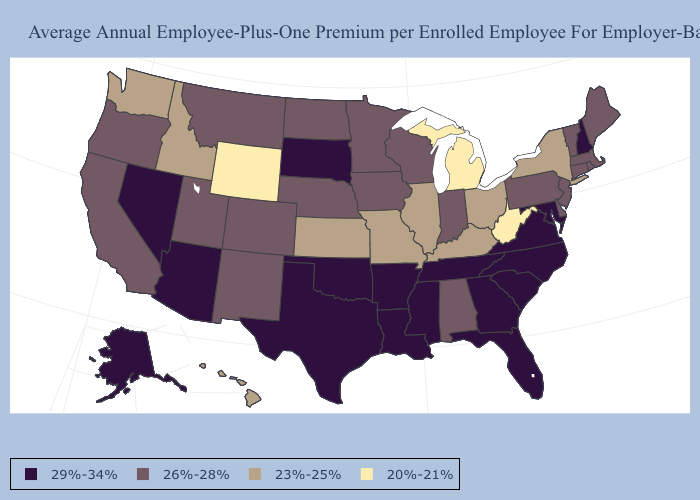Does New Hampshire have the highest value in the USA?
Quick response, please. Yes. Name the states that have a value in the range 23%-25%?
Quick response, please. Hawaii, Idaho, Illinois, Kansas, Kentucky, Missouri, New York, Ohio, Washington. Does Kentucky have a lower value than Oregon?
Write a very short answer. Yes. Name the states that have a value in the range 20%-21%?
Quick response, please. Michigan, West Virginia, Wyoming. Does Connecticut have the highest value in the Northeast?
Concise answer only. No. Which states have the lowest value in the USA?
Keep it brief. Michigan, West Virginia, Wyoming. Does Michigan have the lowest value in the USA?
Write a very short answer. Yes. Name the states that have a value in the range 26%-28%?
Concise answer only. Alabama, California, Colorado, Connecticut, Delaware, Indiana, Iowa, Maine, Massachusetts, Minnesota, Montana, Nebraska, New Jersey, New Mexico, North Dakota, Oregon, Pennsylvania, Rhode Island, Utah, Vermont, Wisconsin. Does the map have missing data?
Keep it brief. No. Does Colorado have the highest value in the USA?
Keep it brief. No. What is the value of Pennsylvania?
Concise answer only. 26%-28%. Does New Hampshire have the lowest value in the Northeast?
Short answer required. No. What is the lowest value in the West?
Short answer required. 20%-21%. Does the map have missing data?
Be succinct. No. Does Nevada have the highest value in the West?
Give a very brief answer. Yes. 